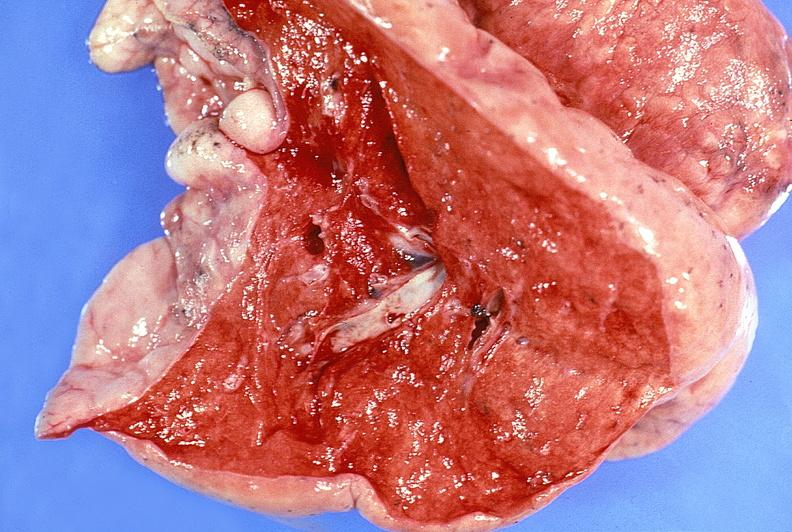what is present?
Answer the question using a single word or phrase. Respiratory 